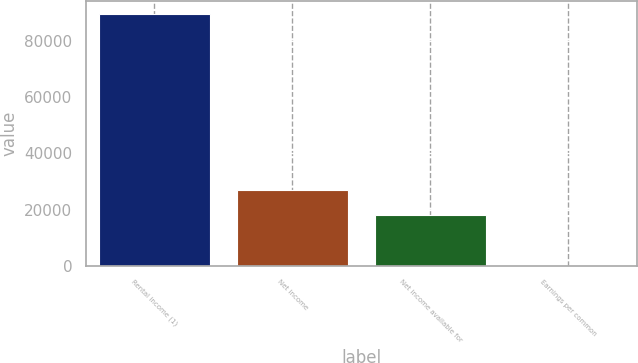<chart> <loc_0><loc_0><loc_500><loc_500><bar_chart><fcel>Rental income (1)<fcel>Net income<fcel>Net income available for<fcel>Earnings per common<nl><fcel>89861<fcel>26958.5<fcel>17972.4<fcel>0.28<nl></chart> 